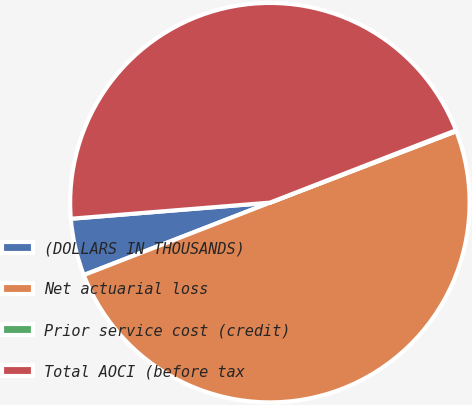Convert chart. <chart><loc_0><loc_0><loc_500><loc_500><pie_chart><fcel>(DOLLARS IN THOUSANDS)<fcel>Net actuarial loss<fcel>Prior service cost (credit)<fcel>Total AOCI (before tax<nl><fcel>4.62%<fcel>49.92%<fcel>0.08%<fcel>45.38%<nl></chart> 